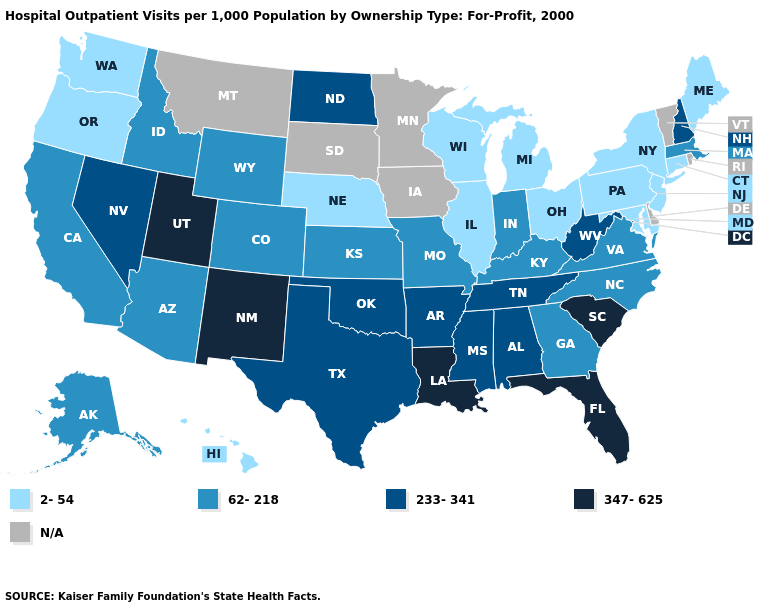Which states have the lowest value in the Northeast?
Quick response, please. Connecticut, Maine, New Jersey, New York, Pennsylvania. Name the states that have a value in the range 62-218?
Keep it brief. Alaska, Arizona, California, Colorado, Georgia, Idaho, Indiana, Kansas, Kentucky, Massachusetts, Missouri, North Carolina, Virginia, Wyoming. Name the states that have a value in the range N/A?
Keep it brief. Delaware, Iowa, Minnesota, Montana, Rhode Island, South Dakota, Vermont. Name the states that have a value in the range 233-341?
Short answer required. Alabama, Arkansas, Mississippi, Nevada, New Hampshire, North Dakota, Oklahoma, Tennessee, Texas, West Virginia. How many symbols are there in the legend?
Quick response, please. 5. Among the states that border Utah , which have the lowest value?
Write a very short answer. Arizona, Colorado, Idaho, Wyoming. Does Massachusetts have the highest value in the Northeast?
Give a very brief answer. No. Is the legend a continuous bar?
Keep it brief. No. Among the states that border Nebraska , which have the highest value?
Answer briefly. Colorado, Kansas, Missouri, Wyoming. Is the legend a continuous bar?
Short answer required. No. Among the states that border Ohio , does Indiana have the lowest value?
Give a very brief answer. No. Among the states that border New Mexico , which have the lowest value?
Answer briefly. Arizona, Colorado. Which states have the lowest value in the USA?
Answer briefly. Connecticut, Hawaii, Illinois, Maine, Maryland, Michigan, Nebraska, New Jersey, New York, Ohio, Oregon, Pennsylvania, Washington, Wisconsin. Does the first symbol in the legend represent the smallest category?
Concise answer only. Yes. Name the states that have a value in the range 62-218?
Quick response, please. Alaska, Arizona, California, Colorado, Georgia, Idaho, Indiana, Kansas, Kentucky, Massachusetts, Missouri, North Carolina, Virginia, Wyoming. 